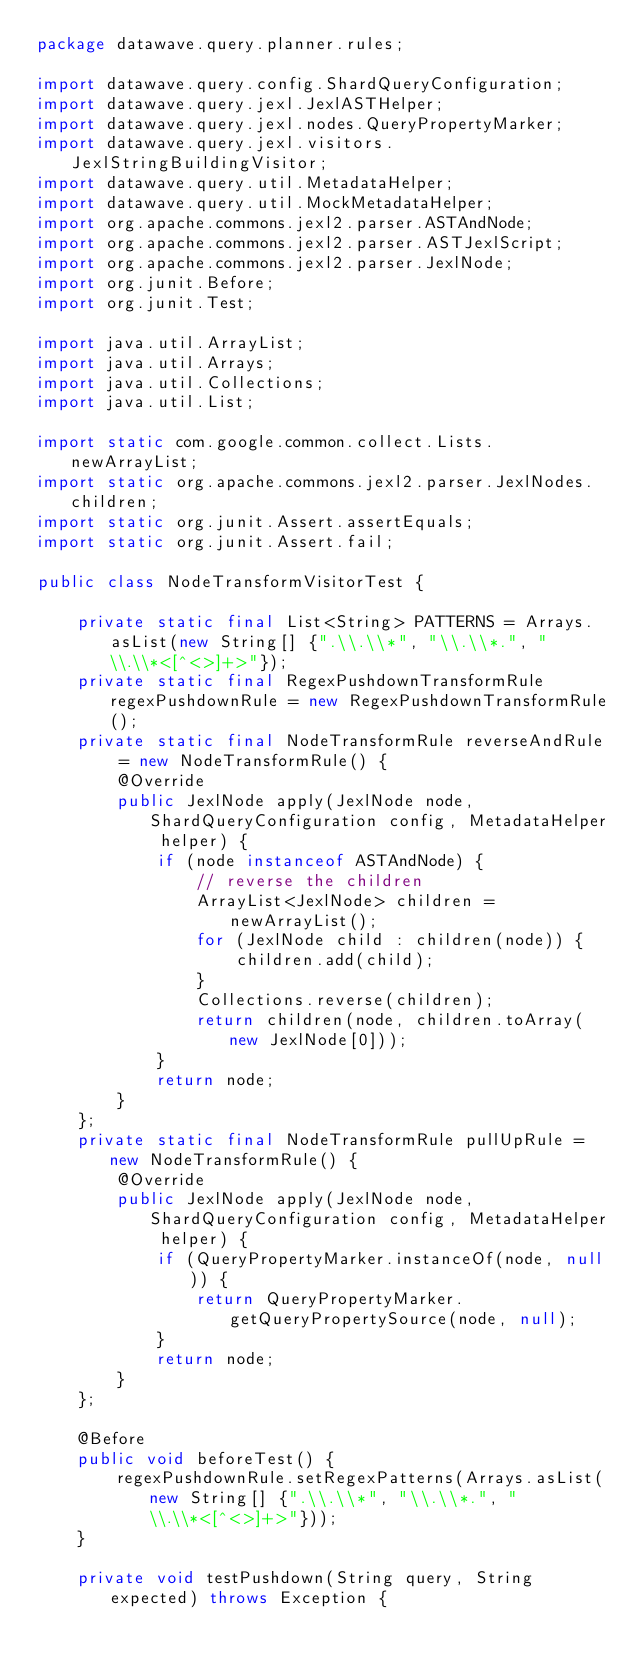<code> <loc_0><loc_0><loc_500><loc_500><_Java_>package datawave.query.planner.rules;

import datawave.query.config.ShardQueryConfiguration;
import datawave.query.jexl.JexlASTHelper;
import datawave.query.jexl.nodes.QueryPropertyMarker;
import datawave.query.jexl.visitors.JexlStringBuildingVisitor;
import datawave.query.util.MetadataHelper;
import datawave.query.util.MockMetadataHelper;
import org.apache.commons.jexl2.parser.ASTAndNode;
import org.apache.commons.jexl2.parser.ASTJexlScript;
import org.apache.commons.jexl2.parser.JexlNode;
import org.junit.Before;
import org.junit.Test;

import java.util.ArrayList;
import java.util.Arrays;
import java.util.Collections;
import java.util.List;

import static com.google.common.collect.Lists.newArrayList;
import static org.apache.commons.jexl2.parser.JexlNodes.children;
import static org.junit.Assert.assertEquals;
import static org.junit.Assert.fail;

public class NodeTransformVisitorTest {
    
    private static final List<String> PATTERNS = Arrays.asList(new String[] {".\\.\\*", "\\.\\*.", "\\.\\*<[^<>]+>"});
    private static final RegexPushdownTransformRule regexPushdownRule = new RegexPushdownTransformRule();
    private static final NodeTransformRule reverseAndRule = new NodeTransformRule() {
        @Override
        public JexlNode apply(JexlNode node, ShardQueryConfiguration config, MetadataHelper helper) {
            if (node instanceof ASTAndNode) {
                // reverse the children
                ArrayList<JexlNode> children = newArrayList();
                for (JexlNode child : children(node)) {
                    children.add(child);
                }
                Collections.reverse(children);
                return children(node, children.toArray(new JexlNode[0]));
            }
            return node;
        }
    };
    private static final NodeTransformRule pullUpRule = new NodeTransformRule() {
        @Override
        public JexlNode apply(JexlNode node, ShardQueryConfiguration config, MetadataHelper helper) {
            if (QueryPropertyMarker.instanceOf(node, null)) {
                return QueryPropertyMarker.getQueryPropertySource(node, null);
            }
            return node;
        }
    };
    
    @Before
    public void beforeTest() {
        regexPushdownRule.setRegexPatterns(Arrays.asList(new String[] {".\\.\\*", "\\.\\*.", "\\.\\*<[^<>]+>"}));
    }
    
    private void testPushdown(String query, String expected) throws Exception {</code> 